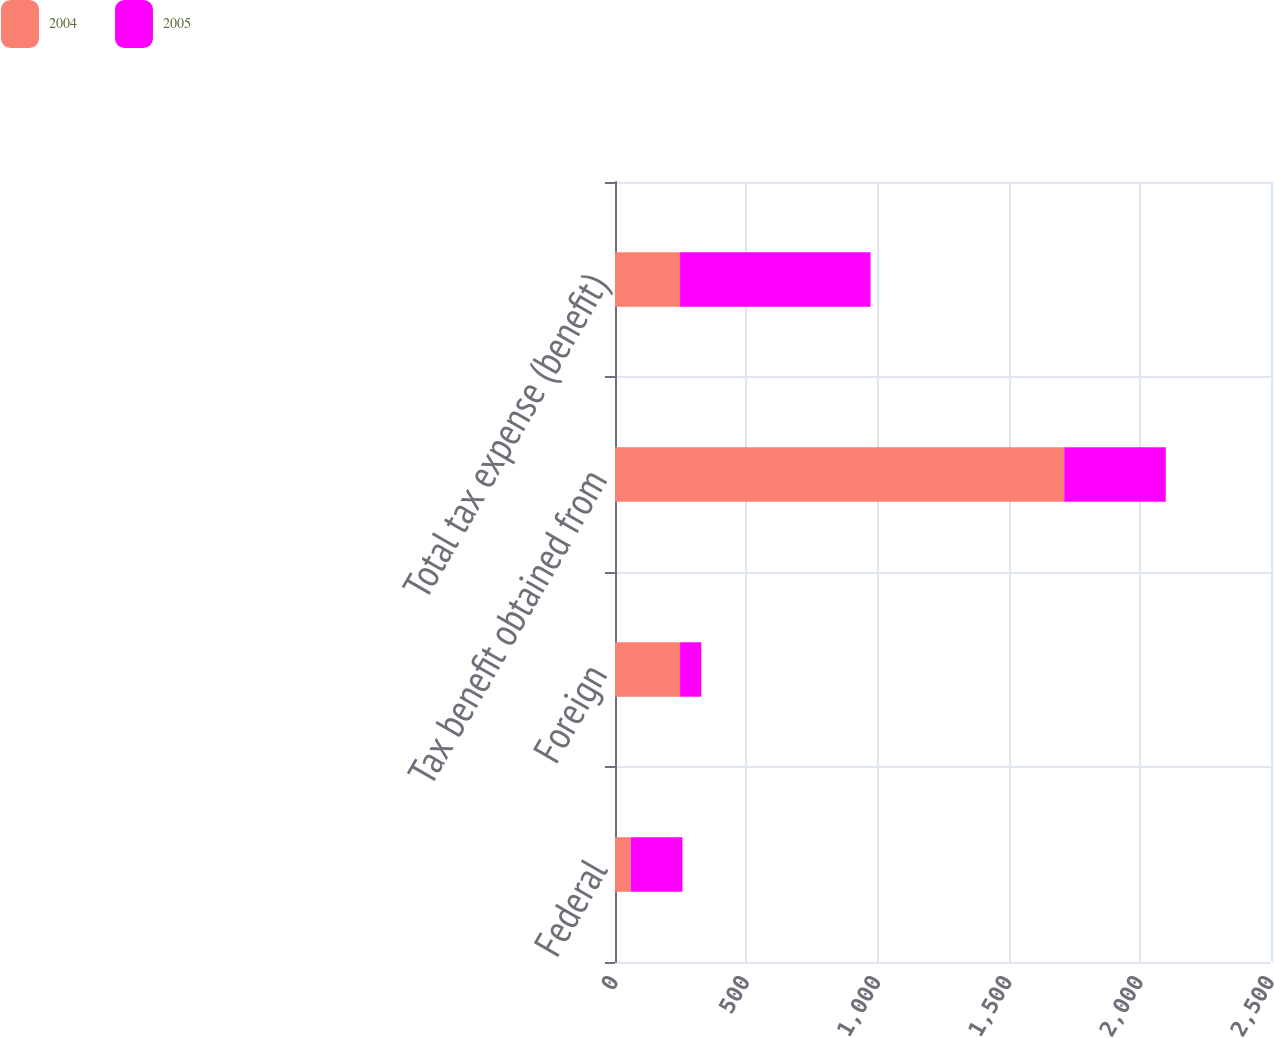Convert chart. <chart><loc_0><loc_0><loc_500><loc_500><stacked_bar_chart><ecel><fcel>Federal<fcel>Foreign<fcel>Tax benefit obtained from<fcel>Total tax expense (benefit)<nl><fcel>2004<fcel>60<fcel>248<fcel>1712<fcel>248<nl><fcel>2005<fcel>197<fcel>81<fcel>387<fcel>726<nl></chart> 